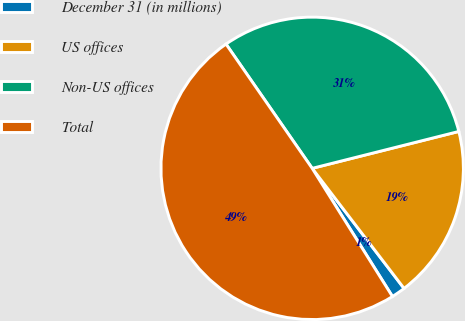<chart> <loc_0><loc_0><loc_500><loc_500><pie_chart><fcel>December 31 (in millions)<fcel>US offices<fcel>Non-US offices<fcel>Total<nl><fcel>1.49%<fcel>18.53%<fcel>30.73%<fcel>49.26%<nl></chart> 